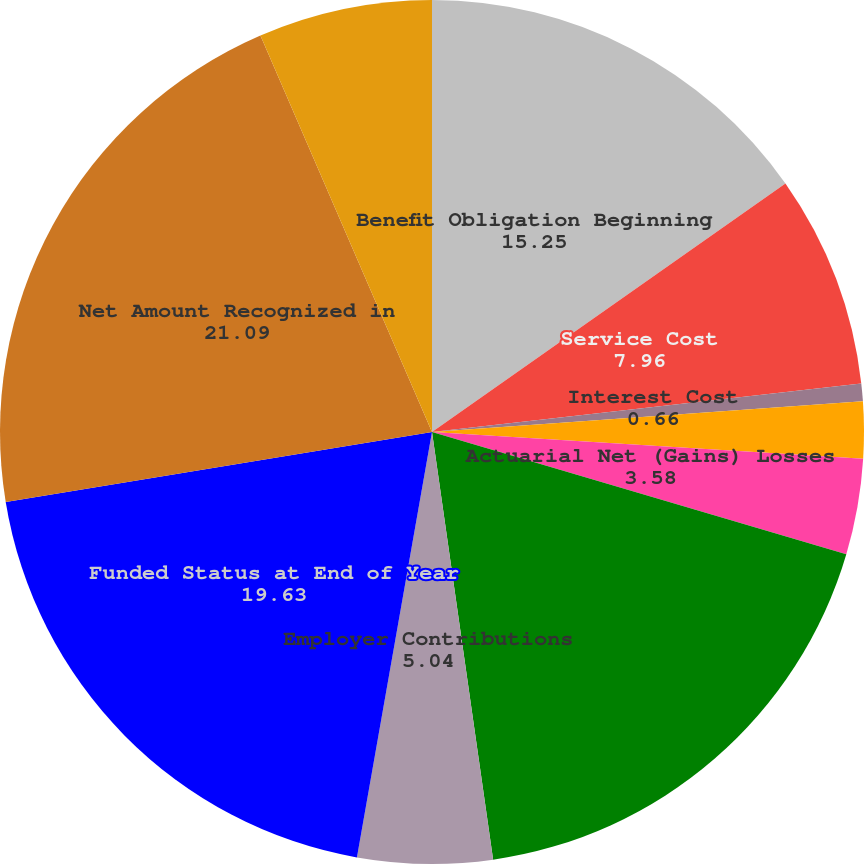<chart> <loc_0><loc_0><loc_500><loc_500><pie_chart><fcel>Benefit Obligation Beginning<fcel>Service Cost<fcel>Interest Cost<fcel>Benefits Paid<fcel>Actuarial Net (Gains) Losses<fcel>Benefit Obligation Ending<fcel>Employer Contributions<fcel>Funded Status at End of Year<fcel>Net Amount Recognized in<fcel>Current Liabilities<nl><fcel>15.25%<fcel>7.96%<fcel>0.66%<fcel>2.12%<fcel>3.58%<fcel>18.17%<fcel>5.04%<fcel>19.63%<fcel>21.09%<fcel>6.5%<nl></chart> 